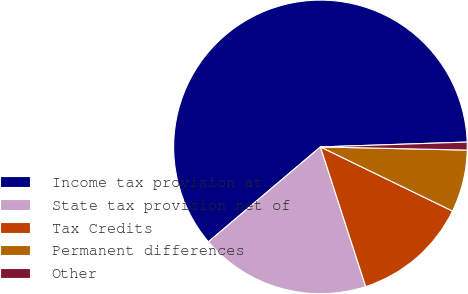Convert chart. <chart><loc_0><loc_0><loc_500><loc_500><pie_chart><fcel>Income tax provision at<fcel>State tax provision net of<fcel>Tax Credits<fcel>Permanent differences<fcel>Other<nl><fcel>60.66%<fcel>18.8%<fcel>12.82%<fcel>6.85%<fcel>0.87%<nl></chart> 